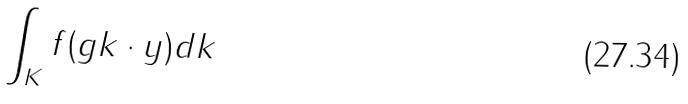<formula> <loc_0><loc_0><loc_500><loc_500>\int _ { K } f ( g k \cdot y ) d k</formula> 